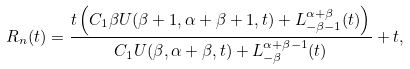<formula> <loc_0><loc_0><loc_500><loc_500>R _ { n } ( t ) = \frac { t \left ( C _ { 1 } \beta U ( \beta + 1 , \alpha + \beta + 1 , t ) + L _ { - \beta - 1 } ^ { \alpha + \beta } ( t ) \right ) } { C _ { 1 } U ( \beta , \alpha + \beta , t ) + L _ { - \beta } ^ { \alpha + \beta - 1 } ( t ) } + t ,</formula> 